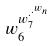<formula> <loc_0><loc_0><loc_500><loc_500>w _ { 6 } ^ { w _ { 7 } ^ { \cdot ^ { \cdot ^ { w _ { n } } } } }</formula> 